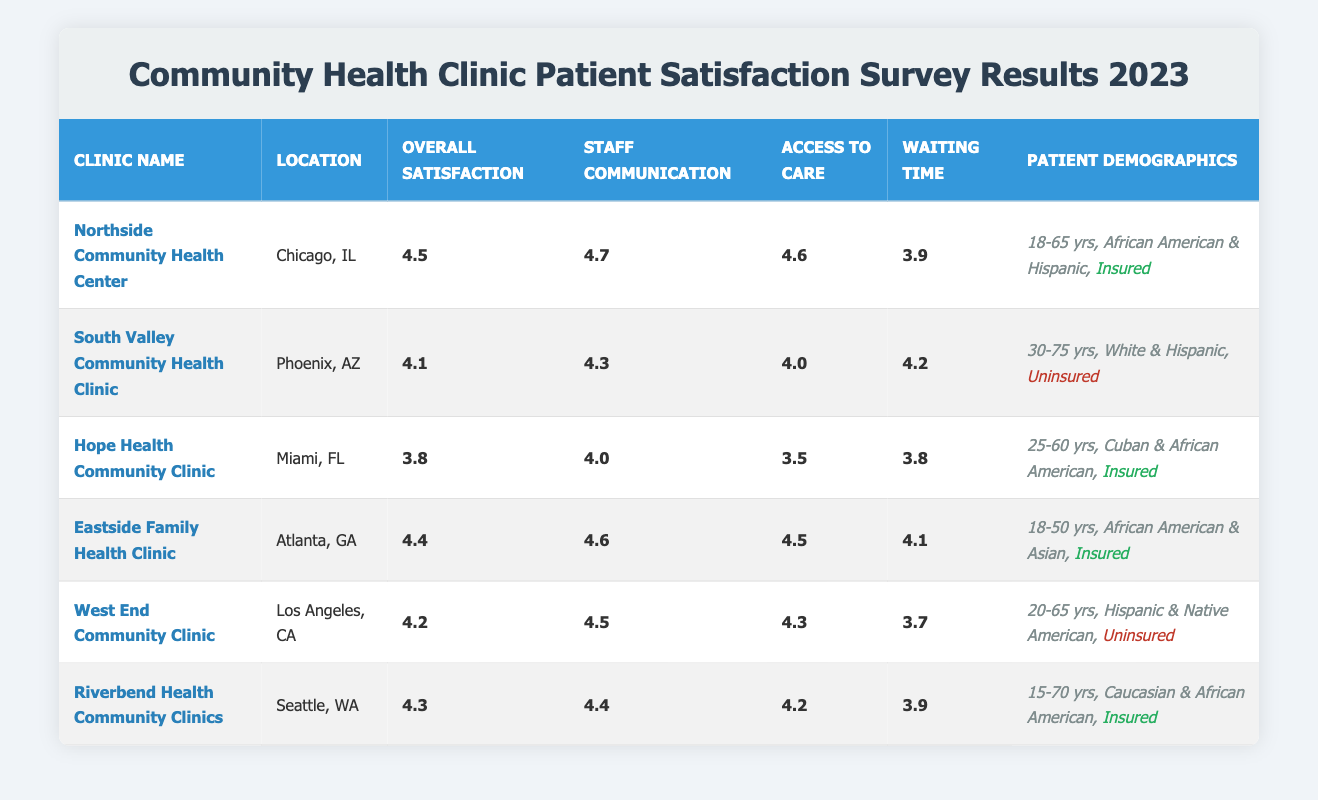What is the Overall Satisfaction Score for the Eastside Family Health Clinic? The Overall Satisfaction Score for the Eastside Family Health Clinic is listed directly in the table under the corresponding column. It shows a score of 4.4.
Answer: 4.4 Which clinic has the highest Staff Communication Score? To find the clinic with the highest Staff Communication Score, we compare the scores listed under the Staff Communication column. The Northside Community Health Center has the highest score at 4.7.
Answer: Northside Community Health Center What is the average Waiting Time Score for all clinics listed? First, we need to sum the Waiting Time Scores: 3.9 (Northside) + 4.2 (South Valley) + 3.8 (Hope Health) + 4.1 (Eastside) + 3.7 (West End) + 3.9 (Riverbend) = 23.6. There are 6 clinics, so we divide 23.6 by 6, resulting in an average of approximately 3.93.
Answer: 3.93 Is the Hope Health Community Clinic insured or uninsured? The Patient Demographics for Hope Health Community Clinic indicate that it is marked as insured. This fact can be directly confirmed from the "Insured" label in the corresponding row of the table.
Answer: Insured Are there any clinics with a Waiting Time Score above 4.0? By reviewing the Waiting Time column, we can see that the South Valley (4.2), Eastside (4.1), and Riverbend (3.9) have scores above 4.0. South Valley and Eastside have scores higher than 4.0.
Answer: Yes What is the difference in Overall Satisfaction Scores between the highest and lowest-rated clinics? The highest Overall Satisfaction Score is 4.5 for Northside Community Health Center, and the lowest is 3.8 for Hope Health Community Clinic. Thus, the difference is calculated as 4.5 - 3.8 = 0.7.
Answer: 0.7 How many clinics have patients aged 30 and below? Reviewing the Patient Demographics section, we find that the age ranges for each clinic either meet or exceed 30 years old. Since none of the listed clinics include age ranges that extend below 30, the count is zero.
Answer: 0 Which ethnicity appears the most among the patient demographics listed? Inspecting the ethnicities listed across the clinics, we see African American mentioned in Northside, Eastside, and Hope Health clinics, while Hispanic appears in Northside, South Valley, and West End clinics. However, African American appears in 3 clinics, making it the most common.
Answer: African American Does Riverbend Health Community Clinic have the lowest Access to Care Score? By looking at the Access to Care Scores, Riverbend has a score of 4.2, which is not the lowest. Hope Health has the lowest score at 3.5. Therefore, Riverbend does not hold the lowest score.
Answer: No 